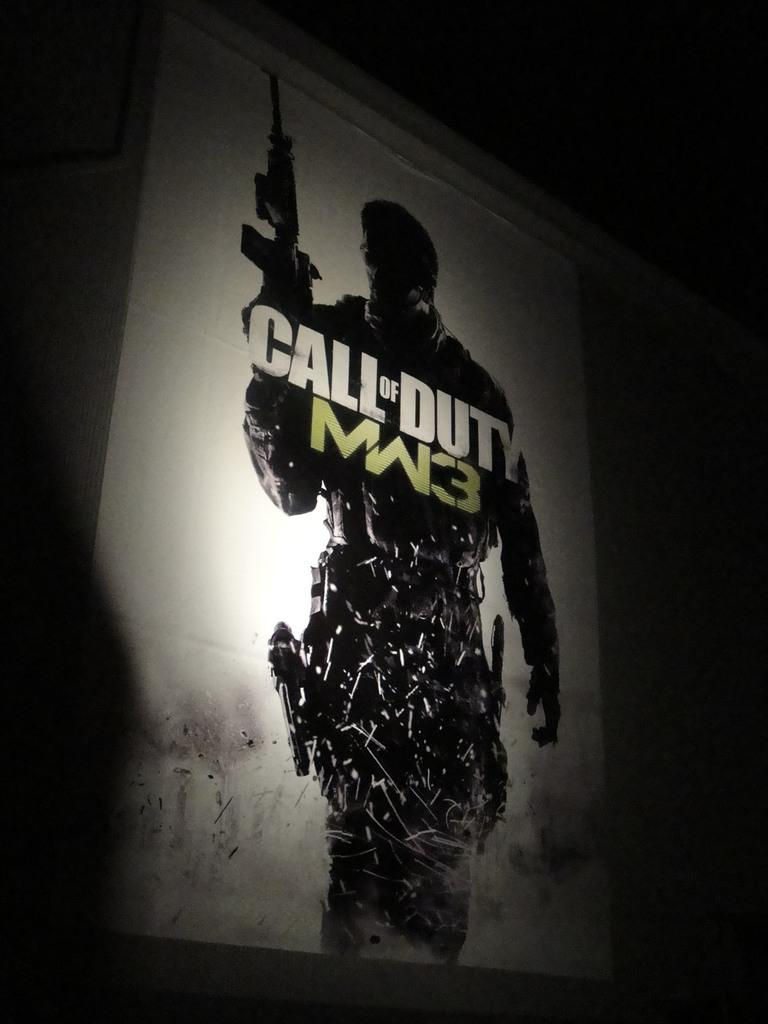What is on the wall in the center of the image? There is a poster on the wall in the center of the image. What is the subject of the poster? The poster depicts a person holding a gun. How does the crowd react to the coach in the image? There is no crowd or coach present in the image; it only features a poster with a person holding a gun. 